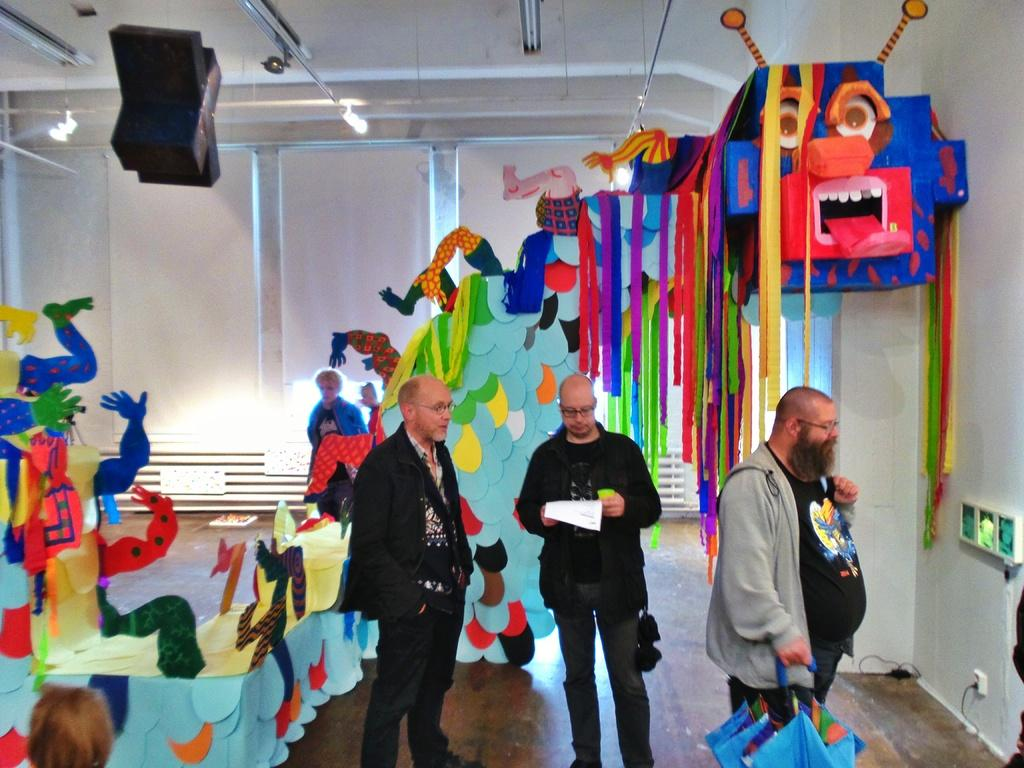What are the people in the image doing? The people in the image are standing on the floor. What object can be seen in the image that is typically used for protection from rain? There is an umbrella in the image. What type of item can be seen in the image that might contain written information? There is a paper in the image. What can be seen in the image that adds to the visual appeal of the setting? Decorative items are present in the image. What can be seen in the image that provides illumination? Lights are visible in the image. What can be seen in the image that might be used for various purposes? There are objects in the image. What can be seen in the background of the image that serves as a barrier or boundary? There is a wall in the background of the image. What type of pie is being served on the wall in the image? There is no pie present in the image, and the wall does not serve as a surface for serving food. 